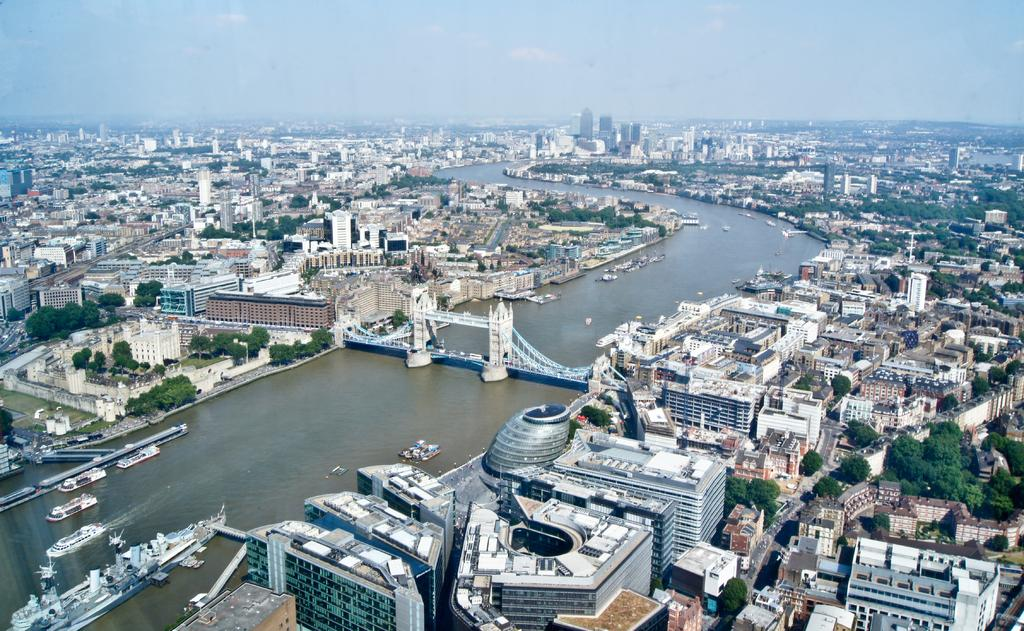What type of view is shown in the image? The image is an aerial view of a city. What can be seen on the river in the image? There are boats and ships on the river. What connects the two sides of the river in the image? There is a bridge over the river. What structures are present in the city? There are buildings in the city. What type of vegetation is present in the city? Trees are present in the city. What is visible in the background of the image? The sky is visible in the image. What type of sticks are being used to walk on the river in the image? There are no sticks or people walking on the river in the image; it shows boats and ships on the water. What color is the dust covering the trees in the image? There is no dust present in the image; it shows trees with leaves. 